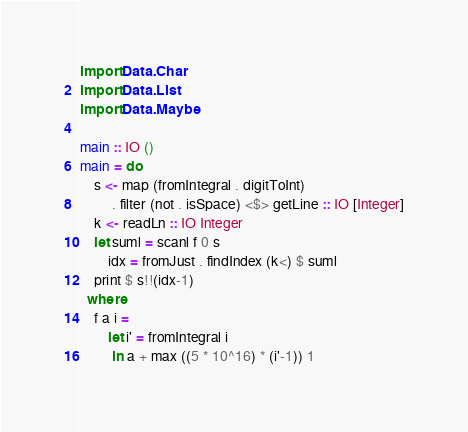Convert code to text. <code><loc_0><loc_0><loc_500><loc_500><_Haskell_>import Data.Char
import Data.List
import Data.Maybe

main :: IO ()
main = do
    s <- map (fromIntegral . digitToInt)
         . filter (not . isSpace) <$> getLine :: IO [Integer]
    k <- readLn :: IO Integer
    let suml = scanl f 0 s
        idx = fromJust . findIndex (k<) $ suml
    print $ s!!(idx-1)
  where
    f a i =
        let i' = fromIntegral i
         in a + max ((5 * 10^16) * (i'-1)) 1</code> 